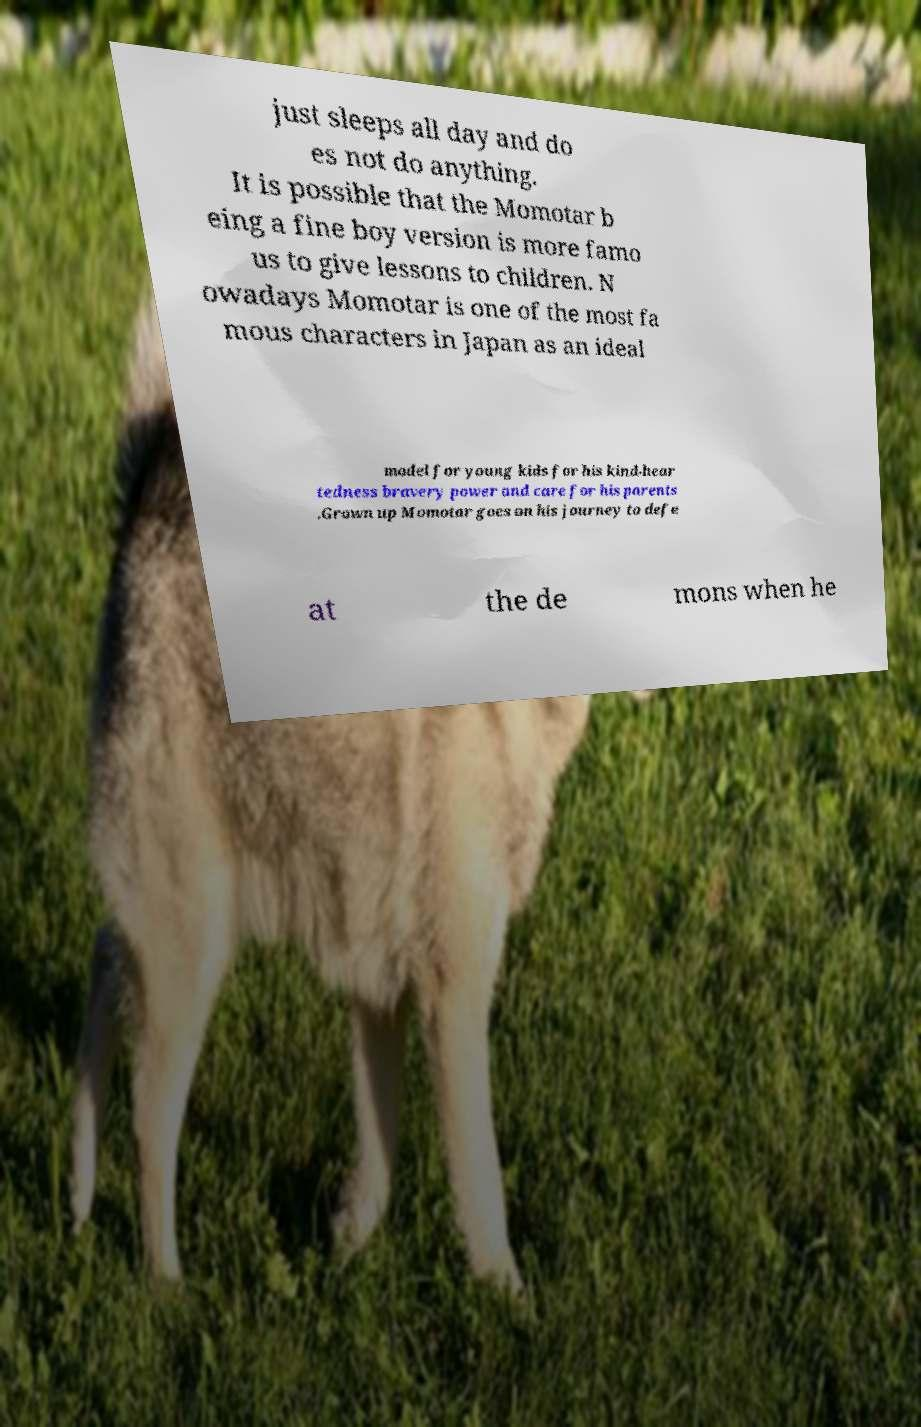There's text embedded in this image that I need extracted. Can you transcribe it verbatim? just sleeps all day and do es not do anything. It is possible that the Momotar b eing a fine boy version is more famo us to give lessons to children. N owadays Momotar is one of the most fa mous characters in Japan as an ideal model for young kids for his kind-hear tedness bravery power and care for his parents .Grown up Momotar goes on his journey to defe at the de mons when he 